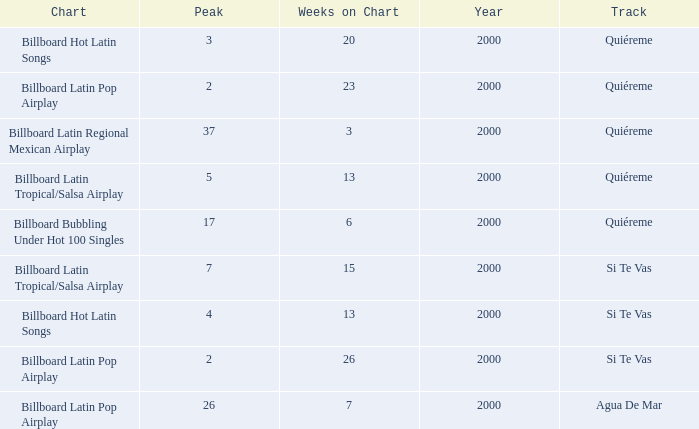Name the least weeks for year less than 2000 None. 